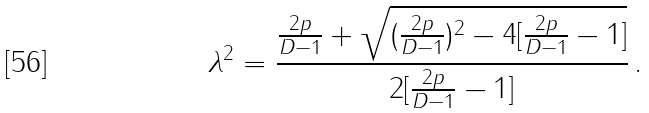Convert formula to latex. <formula><loc_0><loc_0><loc_500><loc_500>\lambda ^ { 2 } = \frac { \frac { 2 p } { D - 1 } + \sqrt { ( \frac { 2 p } { D - 1 } ) ^ { 2 } - 4 [ \frac { 2 p } { D - 1 } - 1 ] } } { 2 [ \frac { 2 p } { D - 1 } - 1 ] } \, .</formula> 